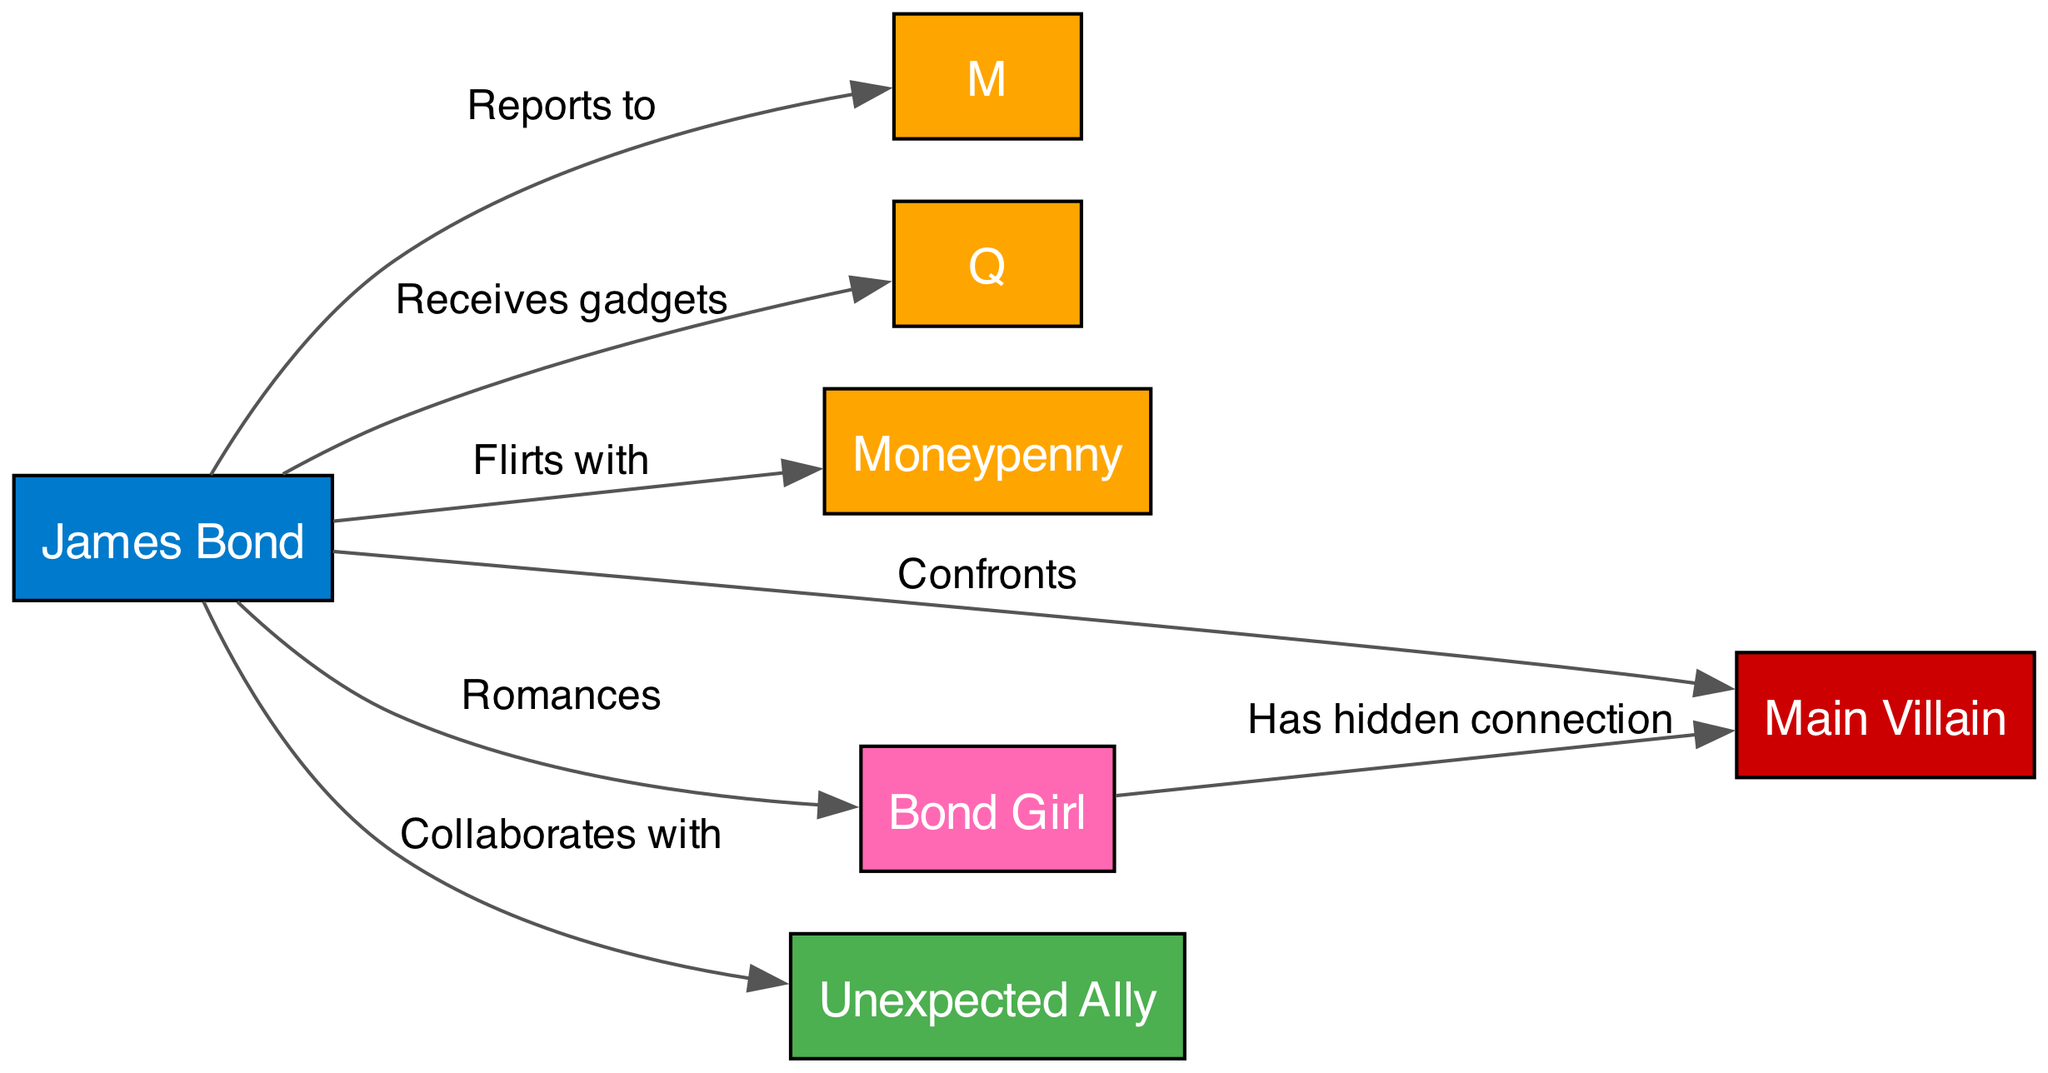What are the total number of characters depicted in the diagram? The diagram includes nodes for James Bond, M, Q, Moneypenny, the Main Villain, the Bond Girl, and an Unexpected Ally. Counting these nodes, there are seven unique characters represented.
Answer: 7 Who does Bond report to? The diagram shows an edge labeled "Reports to" that connects Bond to M, indicating that James Bond's direct superior is M.
Answer: M What type of relationship does Bond have with Moneypenny? The edge labeled "Flirts with" connects Bond and Moneypenny, indicating a flirtatious relationship between the two characters as shown in the diagram.
Answer: Flirts with How many relationships does Bond have in the diagram? Examining the edges connected to Bond, he has relationships labeled "Reports to," "Receives gadgets," "Flirts with," "Confronts," "Romances," and "Collaborates with." Counting these gives a total of six distinct relationships.
Answer: 6 What hidden connection is present in the relationships? According to the diagram, the edge connecting the Bond Girl to the Main Villain is labeled "Has hidden connection," which signifies that there is an undisclosed link between these two characters.
Answer: Has hidden connection Who does Bond collaborate with? The diagram indicates that Bond collaborates with an entity labeled as "Unexpected Ally," as indicated by the edge connecting Bond to this character.
Answer: Unexpected Ally Which character provides gadgets to Bond? The diagram has an edge going from Q to Bond labeled "Receives gadgets," meaning Q is the character responsible for providing Bond with gadgets.
Answer: Q Which character is directly confronted by Bond? The relationship between Bond and the Main Villain is shown with the edge labeled "Confronts," indicating that Bond faces off against this character in the narrative.
Answer: Main Villain What overall scenario does Bond's interactions suggest? Analyzing the relationships, it suggests that Bond operates within a network where he has professional ties with M, technical support from Q, flirtation with Moneypenny, personal romantic involvement with the Bond Girl, and ultimately faces the Main Villain, possibly alongside an Unexpected Ally. Thus, it implies a classic Bond storyline of espionage, romance, and conflict.
Answer: Classic Bond storyline 